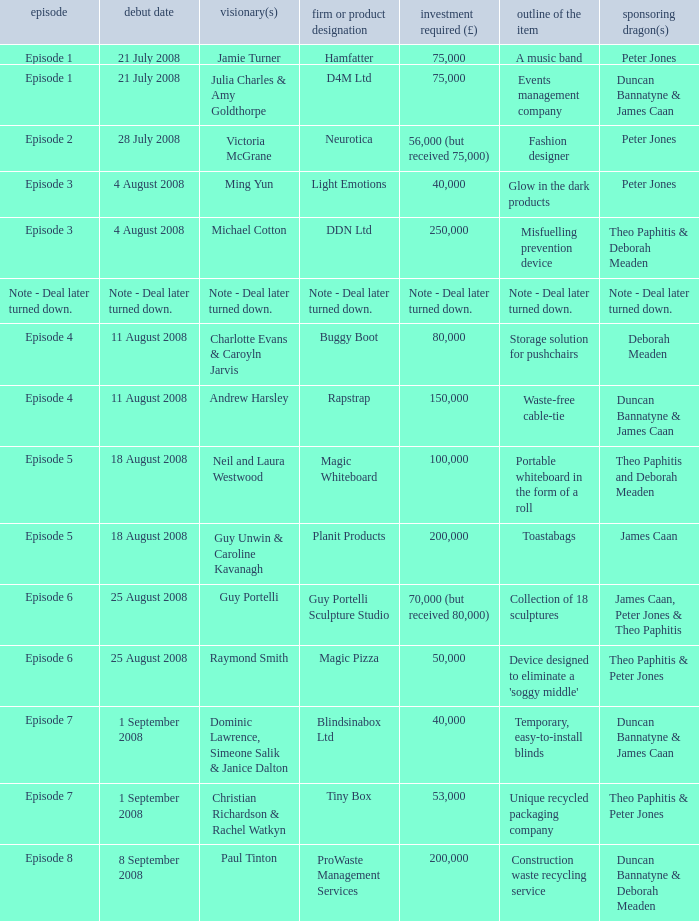Who is the company Investing Dragons, or tiny box? Theo Paphitis & Peter Jones. 